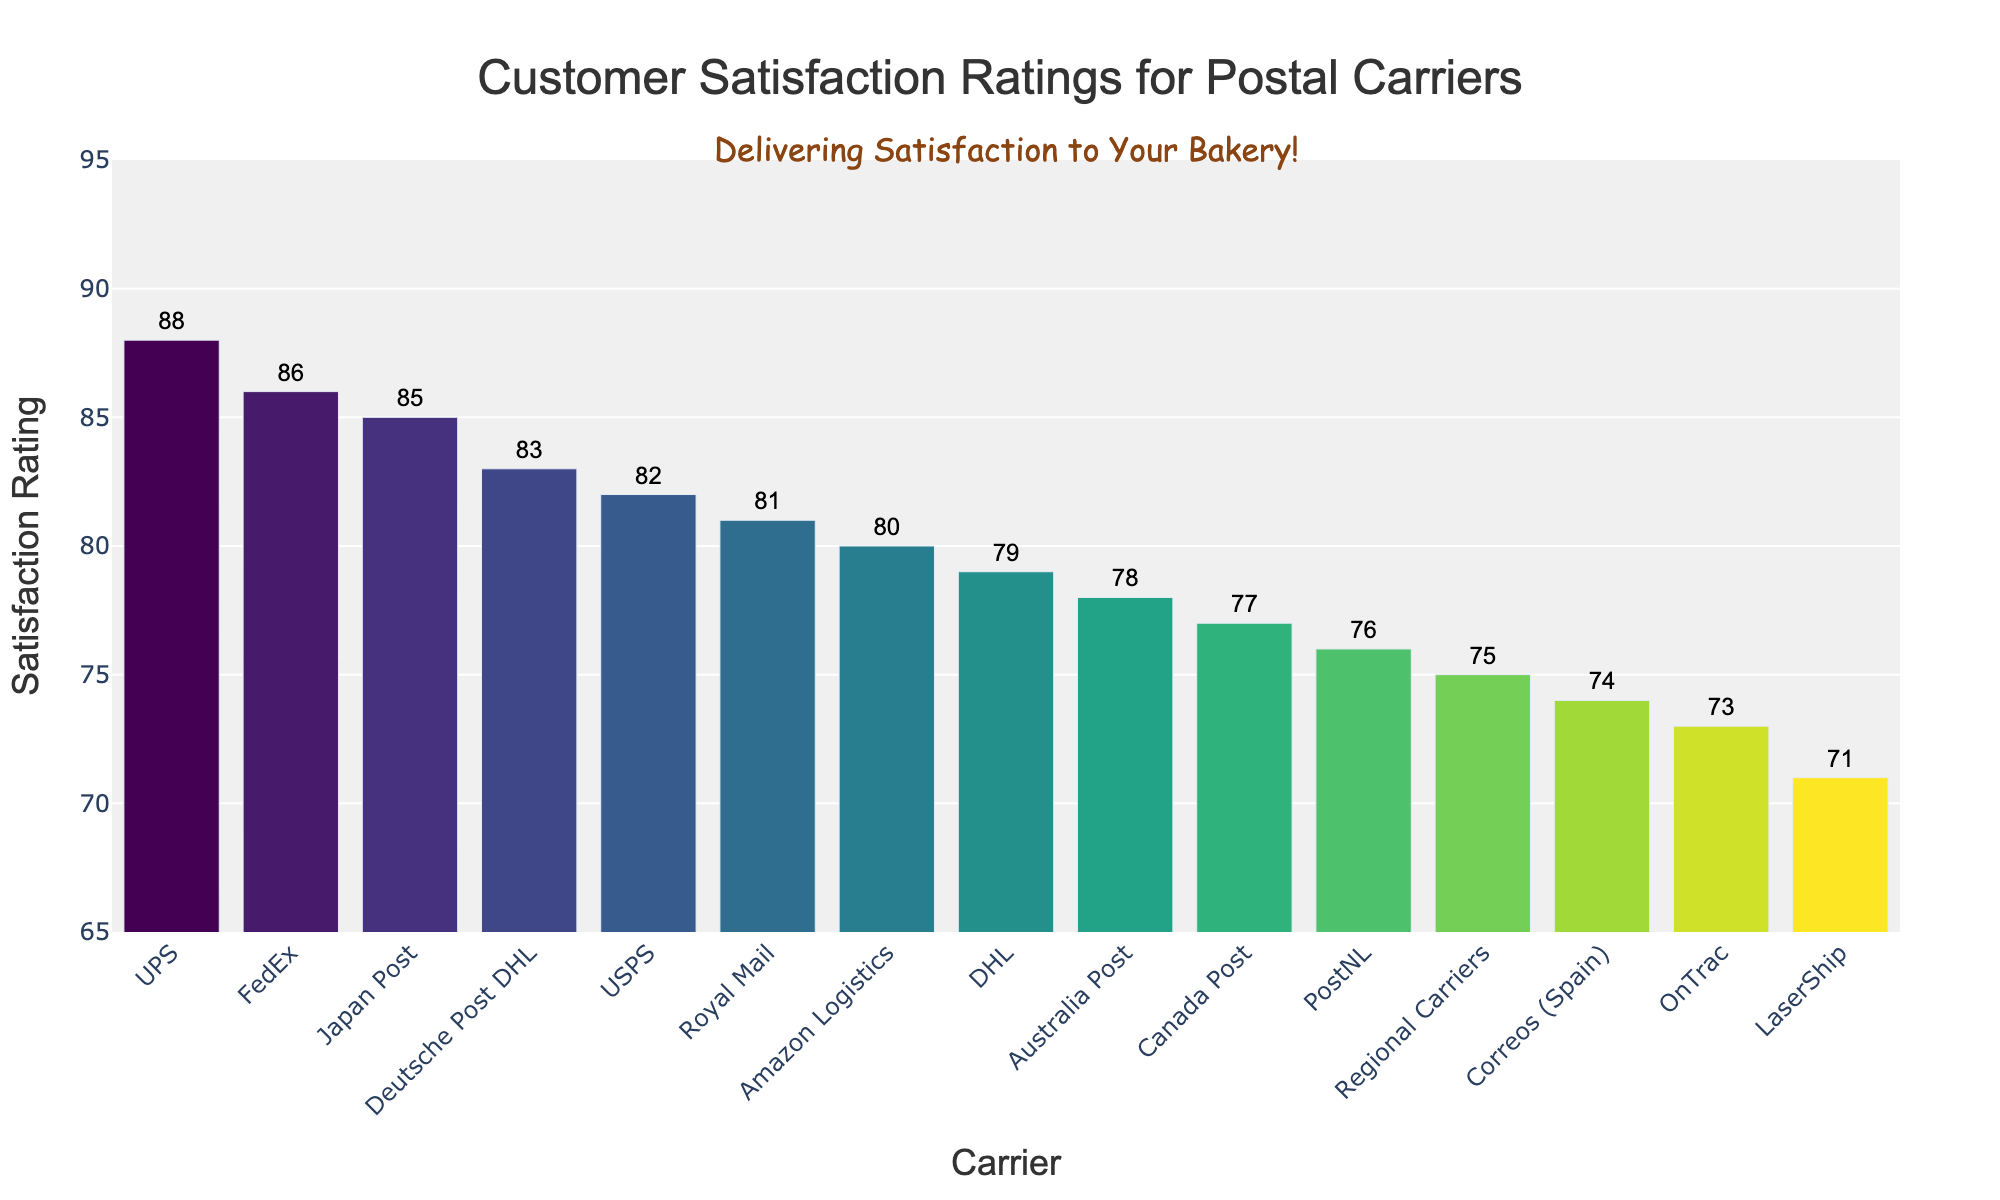Which carrier has the highest customer satisfaction rating? By observing the heights of the bars, the one that stands out as the tallest will have the highest rating, which is UPS with a rating of 88.
Answer: UPS Which carrier has the lowest customer satisfaction rating? By locating the shortest bar among all the bars, it is clear that LaserShip, with a satisfaction rating of 71, has the lowest rating.
Answer: LaserShip What is the difference in satisfaction ratings between UPS and USPS? Locate the bars for UPS and USPS, which have ratings of 88 and 82, respectively. Subtract the USPS rating from the UPS rating (88 - 82) to find the difference.
Answer: 6 Which carriers have ratings higher than 80? Look at all the bars and identify those with ratings above 80. These are USPS (82), UPS (88), FedEx (86), Amazon Logistics (80), Deutsche Post DHL (83), Japan Post (85), and Royal Mail (81).
Answer: USPS, UPS, FedEx, Amazon Logistics, Deutsche Post DHL, Japan Post, Royal Mail How many carriers have satisfaction ratings below 75? Identify the bars representing satisfaction ratings below 75: OnTrac (73), LaserShip (71), Correos (Spain) (74). Count these carriers.
Answer: 3 What are the average satisfaction ratings of Regional Carriers and PostNL combined? Find the ratings for Regional Carriers (75) and PostNL (76). Add them together and divide by 2: (75 + 76) / 2 = 75.5.
Answer: 75.5 Which carrier, between Canada Post and Australia Post, has a higher satisfaction rating? Compare the bars for Canada Post (77) and Australia Post (78). Since 78 is greater than 77, Australia Post has the higher rating.
Answer: Australia Post What's the range of satisfaction ratings among all carriers? Identify the highest rating (UPS with 88) and the lowest rating (LaserShip with 71). The range is 88 - 71 = 17.
Answer: 17 Is the satisfaction rating of FedEx higher or lower than DHL? Compare the bars for FedEx (86) and DHL (79). Since 86 is greater than 79, the satisfaction rating of FedEx is higher.
Answer: Higher Which carrier has a satisfaction rating closest to the median of all the ratings? First, list all ratings in order and find the median value. There are 15 ratings, so the 8th value in sorted order is the median, which is PostNL (76). Identify the carrier closest to this median, which is also PostNL.
Answer: PostNL 